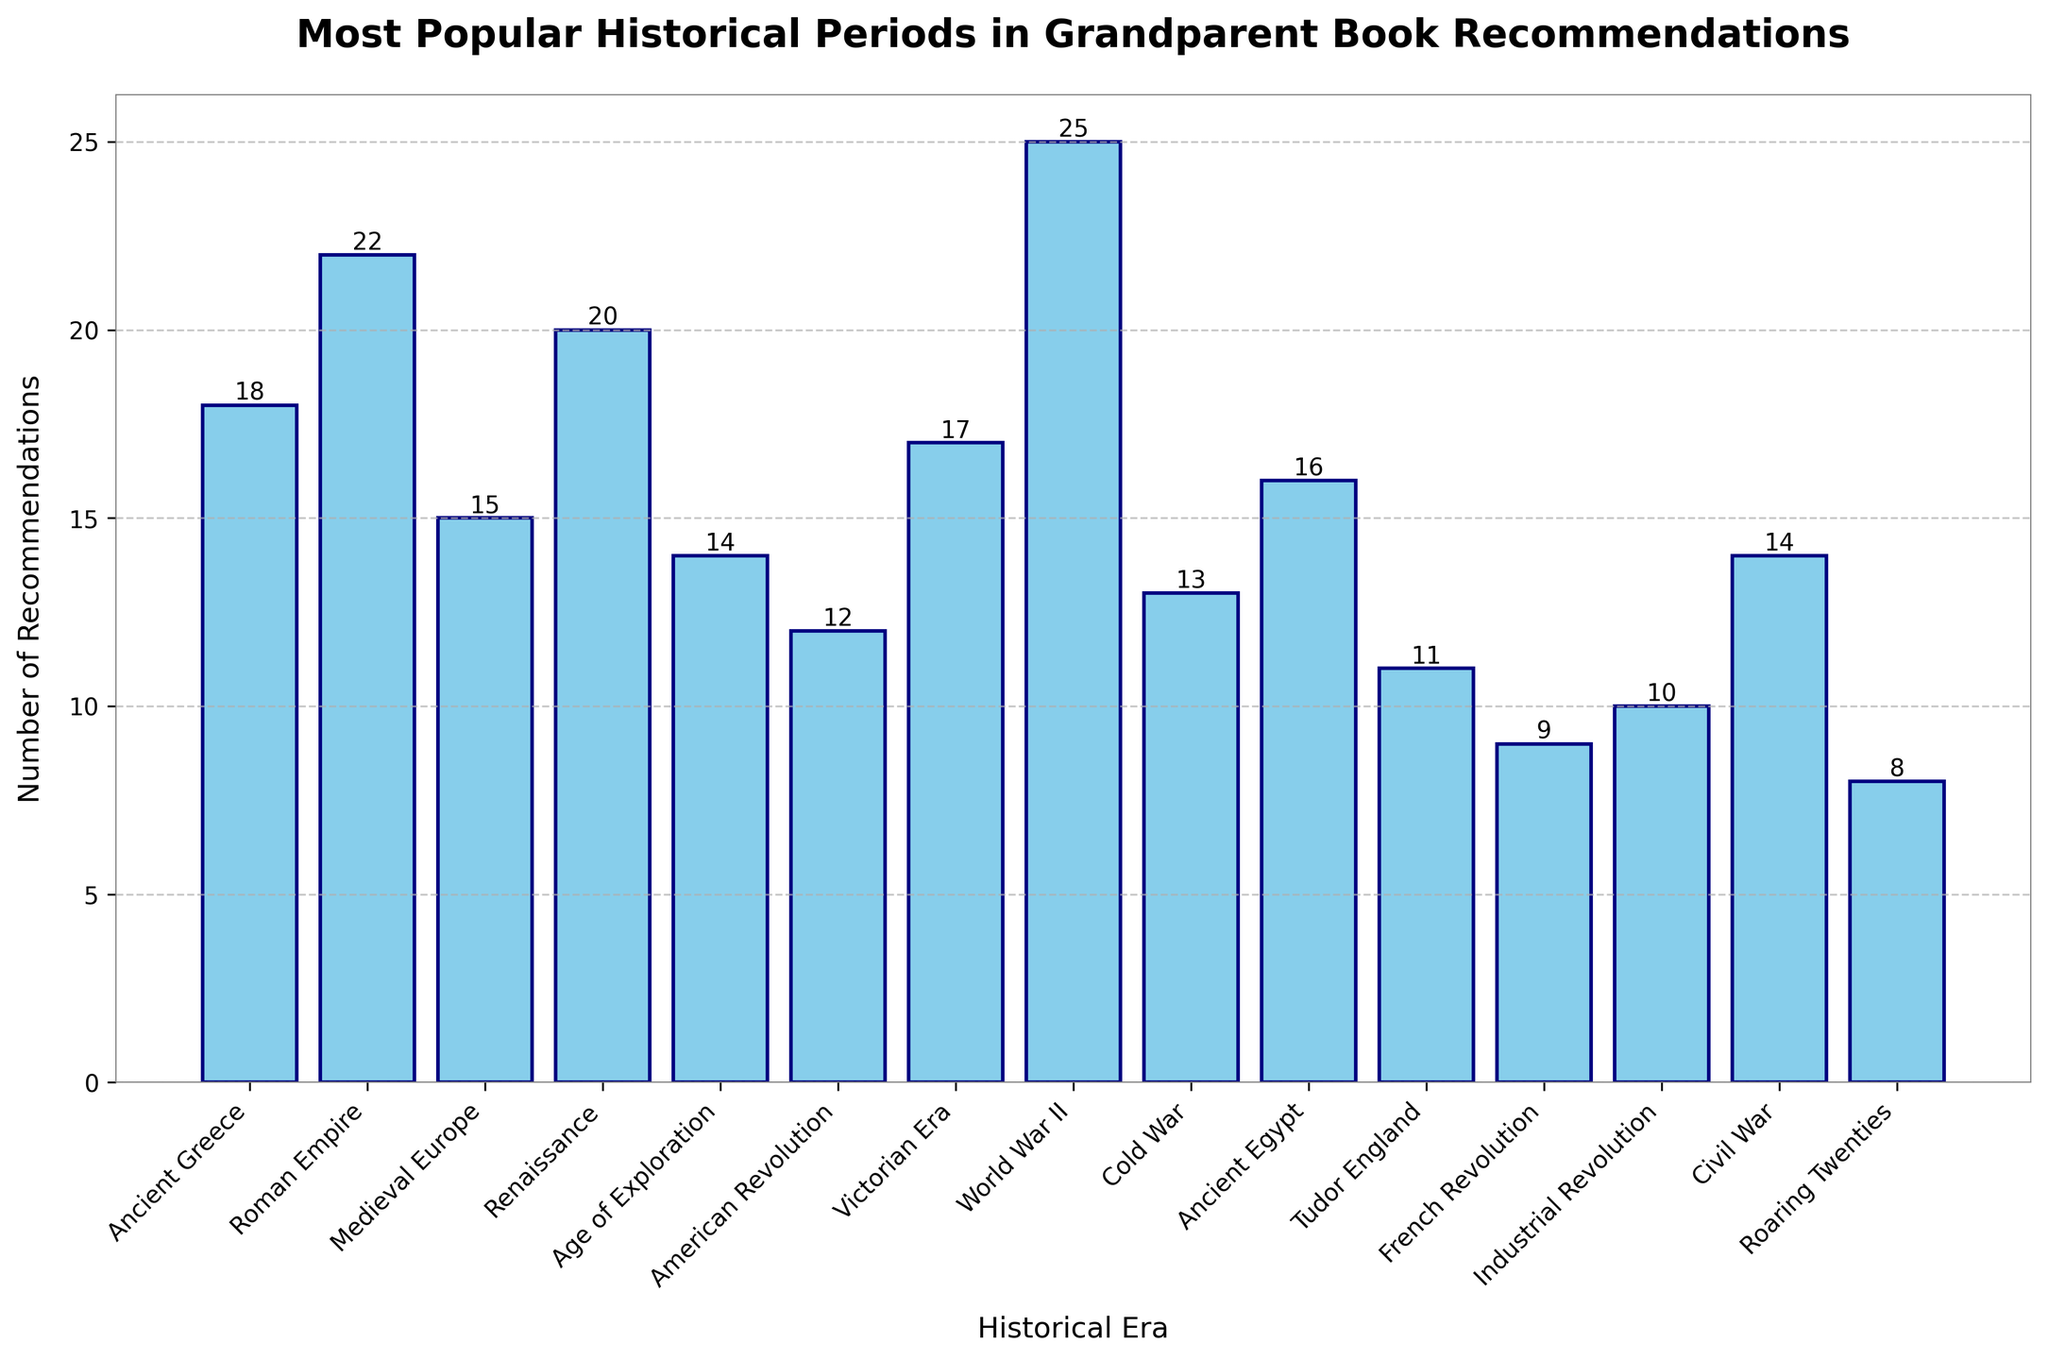What's the most recommended historical period? Identify the bar with the greatest height in the figure. The bar representing "World War II" is the tallest with 25 recommendations.
Answer: World War II Which historical period has the lowest number of recommendations? Find the bar with the shortest height in the figure. The bar representing "Roaring Twenties" is the shortest with 8 recommendations.
Answer: Roaring Twenties What is the difference in the number of recommendations between the Roman Empire and the Civil War? Look at the heights of the bars for "Roman Empire" (22) and "Civil War" (14). Compute the difference: \(22 - 14 = 8\).
Answer: 8 How many historical periods have more than 20 recommendations? Identify bars with heights greater than 20. There are "Roman Empire" (22), "Renaissance" (20), and "World War II" (25), resulting in 2 historical periods.
Answer: 2 What is the total number of recommendations for Ancient Egypt, Tudor England, and the French Revolution together? Sum the values for "Ancient Egypt" (16), "Tudor England" (11), and "French Revolution" (9): \(16 + 11 + 9 = 36\).
Answer: 36 Which era has more recommendations, the Renaissance or the Victorian Era? Compare the heights of "Renaissance" (20) and "Victorian Era" (17). "Renaissance" has more recommendations.
Answer: Renaissance What is the average number of recommendations across all eras? Sum all recommendations and divide by the number of eras: \((18 + 22 + 15 + 20 + 14 + 12 + 17 + 25 + 13 + 16 + 11 + 9 + 10 + 14 + 8) = 214\). There are 15 eras, so, \(214 \div 15 \approx 14.27\).
Answer: 14.27 Which two periods have the closest number of recommendations? Examine the bar heights for each period to find the smallest difference. The smallest difference is between "Industrial Revolution" (10) and "Tudor England" (11) with a difference of 1 recommendation.
Answer: Industrial Revolution and Tudor England Are there more recommendations for ancient periods (Ancient Greece, Roman Empire, Ancient Egypt) or modern periods (Victorian Era, World War II, Cold War)? Sum recommendations for ancient periods: \(18 + 22 + 16 = 56\). Sum recommendations for modern periods: \(17 + 25 + 13 = 55\). There are more for ancient periods (56).
Answer: Ancient periods What's the median number of recommendations? Order the bars by height: 8, 9, 10, 11, 12, 13, 14, 14, 15, 16, 17, 18, 20, 22, 25. The median (middle value) is 14.
Answer: 14 